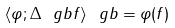Convert formula to latex. <formula><loc_0><loc_0><loc_500><loc_500>\langle \varphi ; \Delta _ { \ } g b f \rangle _ { \ } g b = \varphi ( f )</formula> 